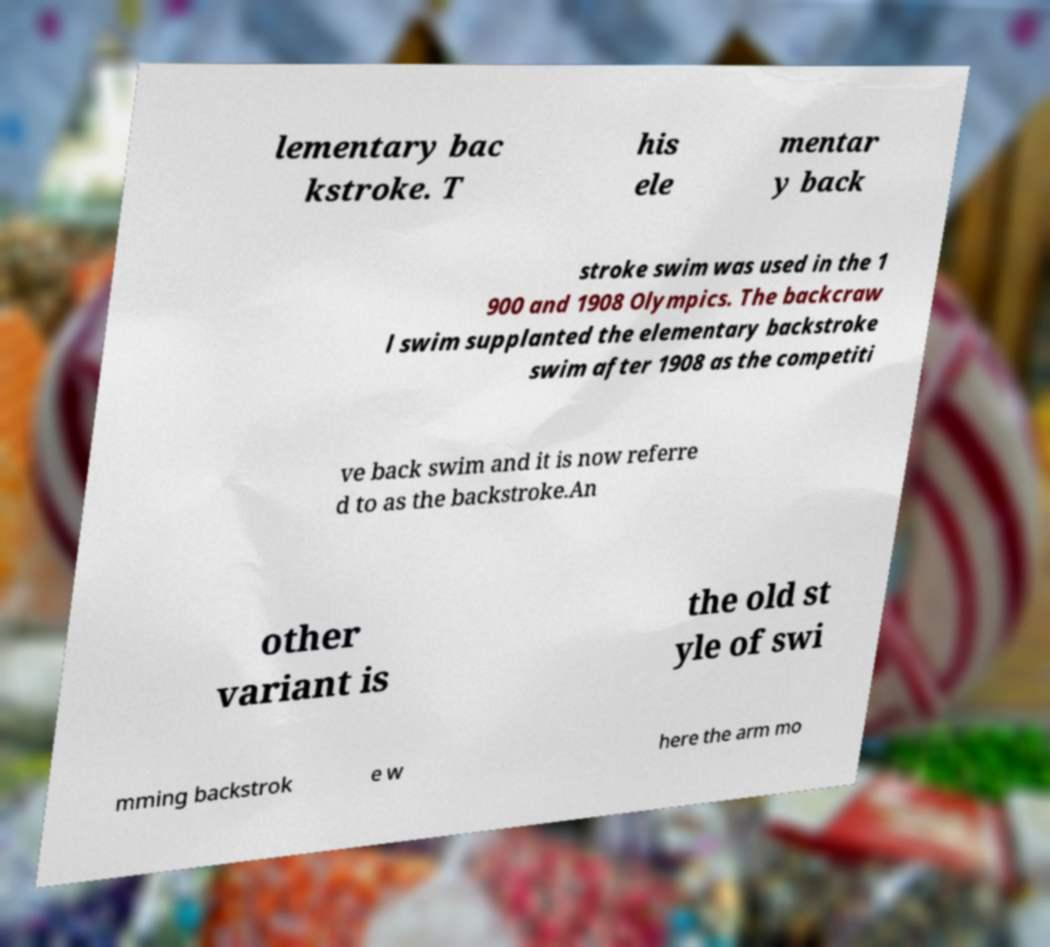Could you assist in decoding the text presented in this image and type it out clearly? lementary bac kstroke. T his ele mentar y back stroke swim was used in the 1 900 and 1908 Olympics. The backcraw l swim supplanted the elementary backstroke swim after 1908 as the competiti ve back swim and it is now referre d to as the backstroke.An other variant is the old st yle of swi mming backstrok e w here the arm mo 